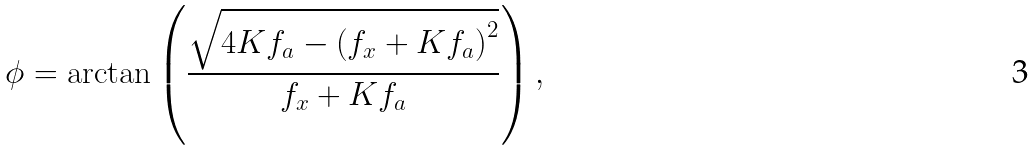<formula> <loc_0><loc_0><loc_500><loc_500>\phi = \arctan \left ( \frac { \sqrt { 4 K f _ { a } - \left ( f _ { x } + K f _ { a } \right ) ^ { 2 } } } { f _ { x } + K f _ { a } } \right ) ,</formula> 